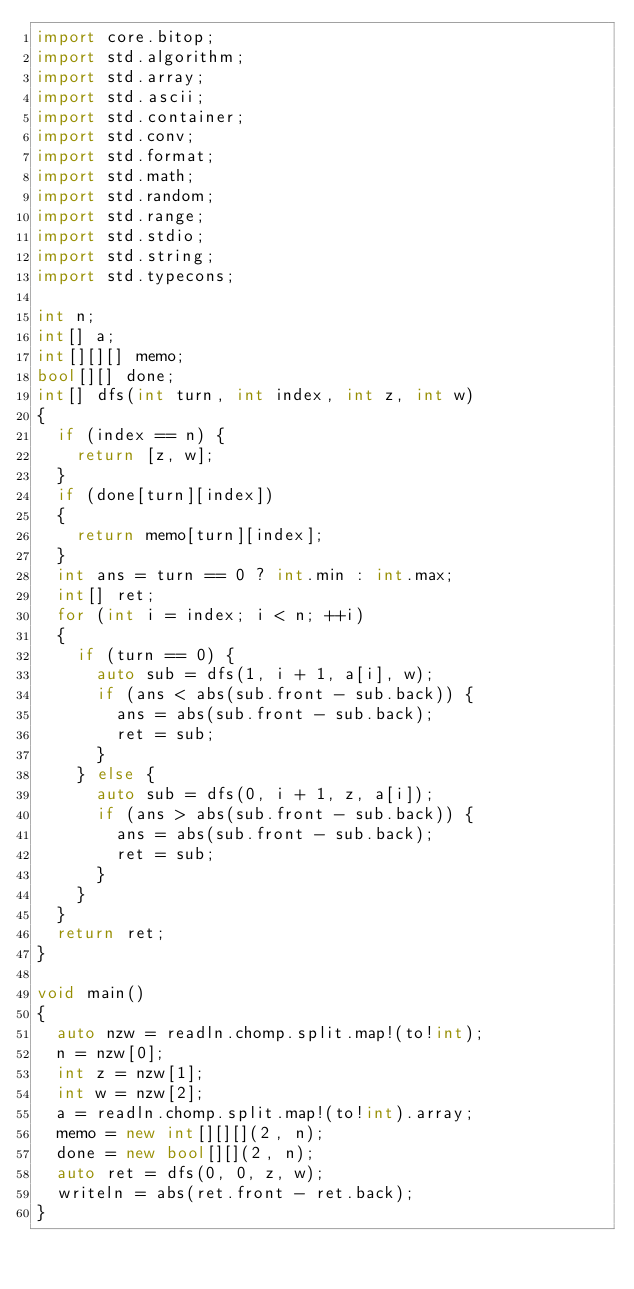Convert code to text. <code><loc_0><loc_0><loc_500><loc_500><_D_>import core.bitop;
import std.algorithm;
import std.array;
import std.ascii;
import std.container;
import std.conv;
import std.format;
import std.math;
import std.random;
import std.range;
import std.stdio;
import std.string;
import std.typecons;

int n;
int[] a;
int[][][] memo;
bool[][] done;
int[] dfs(int turn, int index, int z, int w)
{
  if (index == n) {
    return [z, w];
  }
  if (done[turn][index])
  {
    return memo[turn][index];
  }
  int ans = turn == 0 ? int.min : int.max;
  int[] ret;
  for (int i = index; i < n; ++i)
  {
    if (turn == 0) {
      auto sub = dfs(1, i + 1, a[i], w);
      if (ans < abs(sub.front - sub.back)) {
        ans = abs(sub.front - sub.back);
        ret = sub;
      }
    } else {
      auto sub = dfs(0, i + 1, z, a[i]);
      if (ans > abs(sub.front - sub.back)) {
        ans = abs(sub.front - sub.back);
        ret = sub;
      }
    }
  }
  return ret;
}

void main()
{
  auto nzw = readln.chomp.split.map!(to!int);
  n = nzw[0];
  int z = nzw[1];
  int w = nzw[2];
  a = readln.chomp.split.map!(to!int).array;
  memo = new int[][][](2, n);
  done = new bool[][](2, n);
  auto ret = dfs(0, 0, z, w);
  writeln = abs(ret.front - ret.back);
}
</code> 